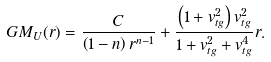<formula> <loc_0><loc_0><loc_500><loc_500>G M _ { U } ( r ) = \frac { C } { \left ( 1 - n \right ) r ^ { n - 1 } } + \frac { \left ( 1 + v _ { t g } ^ { 2 } \right ) v _ { t g } ^ { 2 } } { 1 + v _ { t g } ^ { 2 } + v _ { t g } ^ { 4 } } r .</formula> 